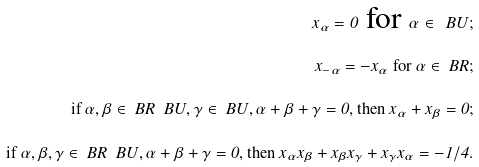Convert formula to latex. <formula><loc_0><loc_0><loc_500><loc_500>x _ { \alpha } = 0 \text { for } \alpha \in \ B U ; \\ x _ { - \alpha } = - x _ { \alpha } \text { for } \alpha \in \ B R ; \\ \text {if } \alpha , \beta \in \ B R \ \ B U , \gamma \in \ B U , \alpha + \beta + \gamma = 0 , \text {then } x _ { \alpha } + x _ { \beta } = 0 ; \\ \text {if } \alpha , \beta , \gamma \in \ B R \ \ B U , \alpha + \beta + \gamma = 0 , \text {then } x _ { \alpha } x _ { \beta } + x _ { \beta } x _ { \gamma } + x _ { \gamma } x _ { \alpha } = - 1 / 4 .</formula> 